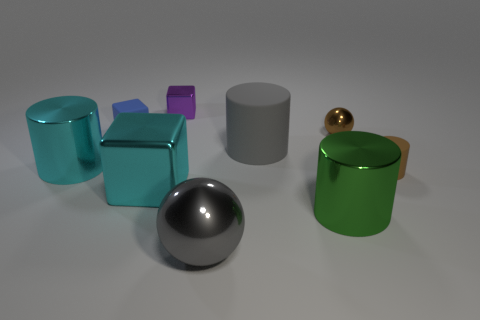Subtract all cubes. How many objects are left? 6 Subtract 0 yellow cubes. How many objects are left? 9 Subtract all tiny blue balls. Subtract all small blue rubber cubes. How many objects are left? 8 Add 3 large gray rubber cylinders. How many large gray rubber cylinders are left? 4 Add 8 brown objects. How many brown objects exist? 10 